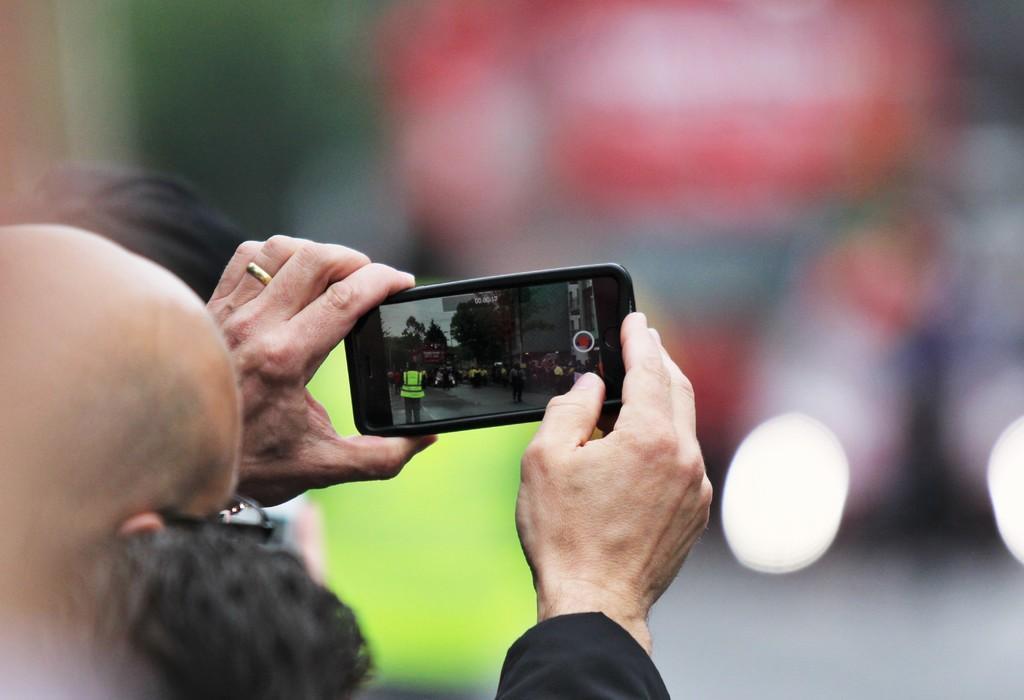In one or two sentences, can you explain what this image depicts? a person is standing , holding a phone in his hand taking a picture. 